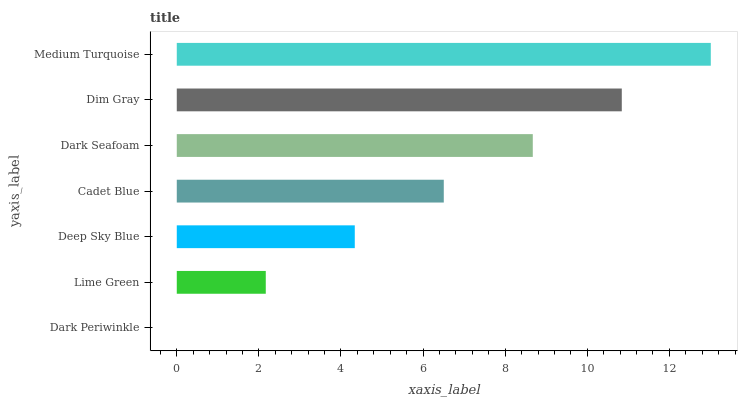Is Dark Periwinkle the minimum?
Answer yes or no. Yes. Is Medium Turquoise the maximum?
Answer yes or no. Yes. Is Lime Green the minimum?
Answer yes or no. No. Is Lime Green the maximum?
Answer yes or no. No. Is Lime Green greater than Dark Periwinkle?
Answer yes or no. Yes. Is Dark Periwinkle less than Lime Green?
Answer yes or no. Yes. Is Dark Periwinkle greater than Lime Green?
Answer yes or no. No. Is Lime Green less than Dark Periwinkle?
Answer yes or no. No. Is Cadet Blue the high median?
Answer yes or no. Yes. Is Cadet Blue the low median?
Answer yes or no. Yes. Is Deep Sky Blue the high median?
Answer yes or no. No. Is Dim Gray the low median?
Answer yes or no. No. 